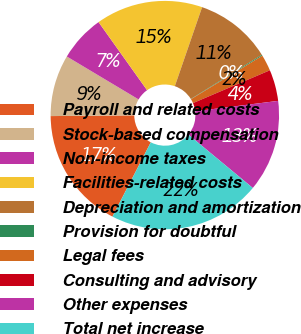Convert chart to OTSL. <chart><loc_0><loc_0><loc_500><loc_500><pie_chart><fcel>Payroll and related costs<fcel>Stock-based compensation<fcel>Non-income taxes<fcel>Facilities-related costs<fcel>Depreciation and amortization<fcel>Provision for doubtful<fcel>Legal fees<fcel>Consulting and advisory<fcel>Other expenses<fcel>Total net increase<nl><fcel>17.28%<fcel>8.71%<fcel>6.57%<fcel>15.14%<fcel>10.86%<fcel>0.14%<fcel>2.29%<fcel>4.43%<fcel>13.0%<fcel>21.57%<nl></chart> 